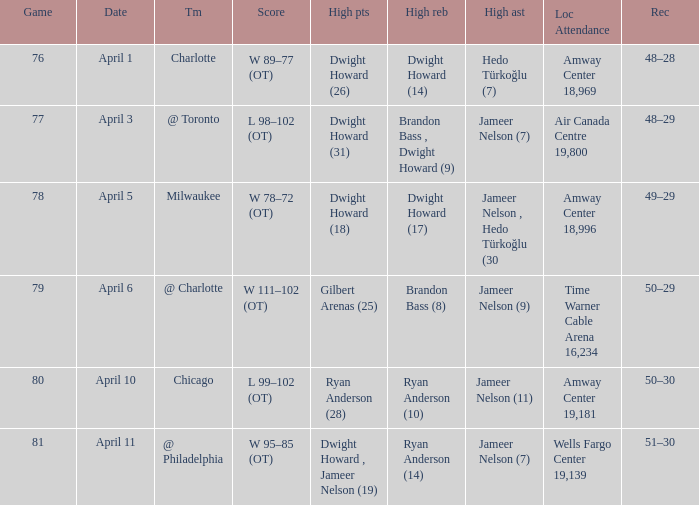Which player had the highest number of rebounds on april 1, and how many did they achieve? Dwight Howard (14). 